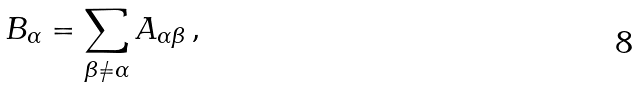Convert formula to latex. <formula><loc_0><loc_0><loc_500><loc_500>B _ { \alpha } = \sum _ { \beta \neq \alpha } A _ { \alpha \beta } \, ,</formula> 